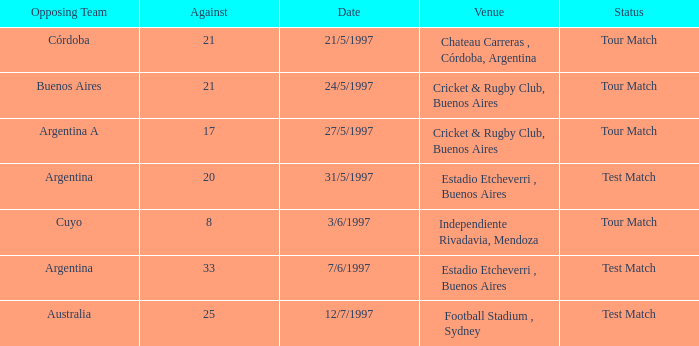What was the mean of againsts on 21/5/1997? 21.0. 